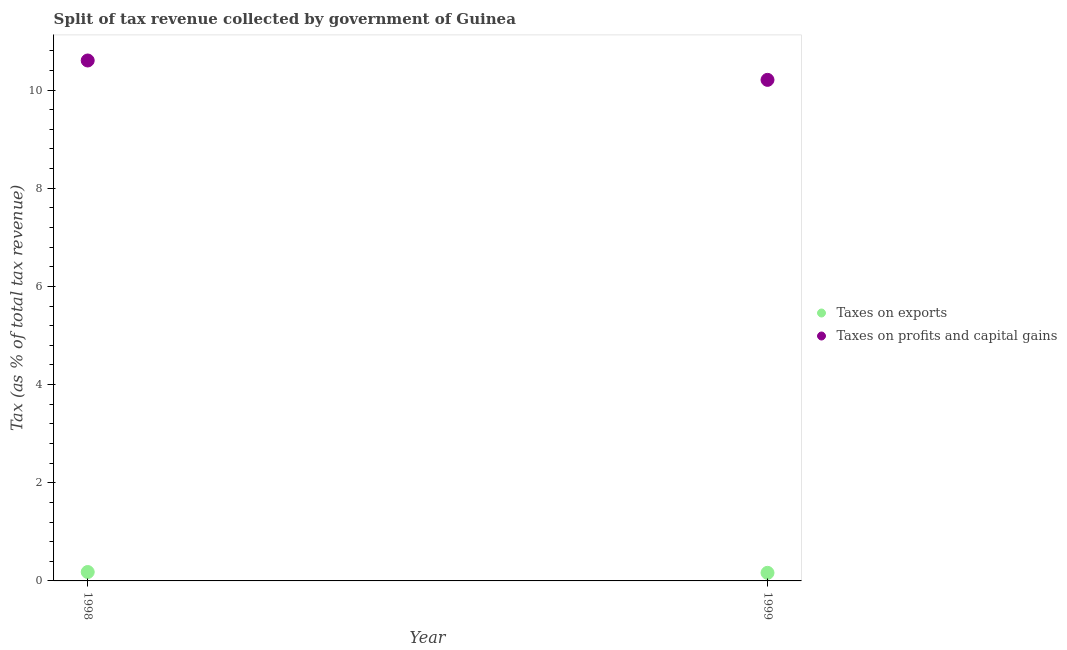How many different coloured dotlines are there?
Give a very brief answer. 2. Is the number of dotlines equal to the number of legend labels?
Offer a very short reply. Yes. What is the percentage of revenue obtained from taxes on profits and capital gains in 1999?
Ensure brevity in your answer.  10.21. Across all years, what is the maximum percentage of revenue obtained from taxes on exports?
Your response must be concise. 0.18. Across all years, what is the minimum percentage of revenue obtained from taxes on exports?
Make the answer very short. 0.16. In which year was the percentage of revenue obtained from taxes on exports minimum?
Provide a succinct answer. 1999. What is the total percentage of revenue obtained from taxes on profits and capital gains in the graph?
Give a very brief answer. 20.81. What is the difference between the percentage of revenue obtained from taxes on profits and capital gains in 1998 and that in 1999?
Keep it short and to the point. 0.39. What is the difference between the percentage of revenue obtained from taxes on exports in 1999 and the percentage of revenue obtained from taxes on profits and capital gains in 1998?
Offer a very short reply. -10.44. What is the average percentage of revenue obtained from taxes on profits and capital gains per year?
Your answer should be very brief. 10.4. In the year 1999, what is the difference between the percentage of revenue obtained from taxes on profits and capital gains and percentage of revenue obtained from taxes on exports?
Keep it short and to the point. 10.04. In how many years, is the percentage of revenue obtained from taxes on profits and capital gains greater than 2 %?
Give a very brief answer. 2. What is the ratio of the percentage of revenue obtained from taxes on exports in 1998 to that in 1999?
Ensure brevity in your answer.  1.1. In how many years, is the percentage of revenue obtained from taxes on exports greater than the average percentage of revenue obtained from taxes on exports taken over all years?
Your answer should be very brief. 1. Does the percentage of revenue obtained from taxes on exports monotonically increase over the years?
Your answer should be compact. No. Is the percentage of revenue obtained from taxes on profits and capital gains strictly less than the percentage of revenue obtained from taxes on exports over the years?
Your answer should be compact. No. How many dotlines are there?
Your response must be concise. 2. What is the difference between two consecutive major ticks on the Y-axis?
Your answer should be compact. 2. Are the values on the major ticks of Y-axis written in scientific E-notation?
Make the answer very short. No. Does the graph contain any zero values?
Your response must be concise. No. Does the graph contain grids?
Your response must be concise. No. Where does the legend appear in the graph?
Offer a very short reply. Center right. How are the legend labels stacked?
Keep it short and to the point. Vertical. What is the title of the graph?
Keep it short and to the point. Split of tax revenue collected by government of Guinea. Does "constant 2005 US$" appear as one of the legend labels in the graph?
Offer a very short reply. No. What is the label or title of the X-axis?
Offer a very short reply. Year. What is the label or title of the Y-axis?
Keep it short and to the point. Tax (as % of total tax revenue). What is the Tax (as % of total tax revenue) of Taxes on exports in 1998?
Provide a short and direct response. 0.18. What is the Tax (as % of total tax revenue) in Taxes on profits and capital gains in 1998?
Ensure brevity in your answer.  10.6. What is the Tax (as % of total tax revenue) in Taxes on exports in 1999?
Offer a very short reply. 0.16. What is the Tax (as % of total tax revenue) in Taxes on profits and capital gains in 1999?
Make the answer very short. 10.21. Across all years, what is the maximum Tax (as % of total tax revenue) in Taxes on exports?
Offer a terse response. 0.18. Across all years, what is the maximum Tax (as % of total tax revenue) of Taxes on profits and capital gains?
Make the answer very short. 10.6. Across all years, what is the minimum Tax (as % of total tax revenue) of Taxes on exports?
Provide a short and direct response. 0.16. Across all years, what is the minimum Tax (as % of total tax revenue) in Taxes on profits and capital gains?
Your answer should be compact. 10.21. What is the total Tax (as % of total tax revenue) in Taxes on exports in the graph?
Provide a short and direct response. 0.35. What is the total Tax (as % of total tax revenue) of Taxes on profits and capital gains in the graph?
Provide a succinct answer. 20.81. What is the difference between the Tax (as % of total tax revenue) of Taxes on exports in 1998 and that in 1999?
Ensure brevity in your answer.  0.02. What is the difference between the Tax (as % of total tax revenue) of Taxes on profits and capital gains in 1998 and that in 1999?
Offer a terse response. 0.39. What is the difference between the Tax (as % of total tax revenue) of Taxes on exports in 1998 and the Tax (as % of total tax revenue) of Taxes on profits and capital gains in 1999?
Offer a terse response. -10.03. What is the average Tax (as % of total tax revenue) in Taxes on exports per year?
Keep it short and to the point. 0.17. What is the average Tax (as % of total tax revenue) in Taxes on profits and capital gains per year?
Make the answer very short. 10.4. In the year 1998, what is the difference between the Tax (as % of total tax revenue) in Taxes on exports and Tax (as % of total tax revenue) in Taxes on profits and capital gains?
Provide a short and direct response. -10.42. In the year 1999, what is the difference between the Tax (as % of total tax revenue) of Taxes on exports and Tax (as % of total tax revenue) of Taxes on profits and capital gains?
Your answer should be compact. -10.04. What is the ratio of the Tax (as % of total tax revenue) of Taxes on exports in 1998 to that in 1999?
Offer a terse response. 1.1. What is the ratio of the Tax (as % of total tax revenue) of Taxes on profits and capital gains in 1998 to that in 1999?
Offer a terse response. 1.04. What is the difference between the highest and the second highest Tax (as % of total tax revenue) of Taxes on exports?
Your answer should be very brief. 0.02. What is the difference between the highest and the second highest Tax (as % of total tax revenue) in Taxes on profits and capital gains?
Make the answer very short. 0.39. What is the difference between the highest and the lowest Tax (as % of total tax revenue) in Taxes on exports?
Your answer should be compact. 0.02. What is the difference between the highest and the lowest Tax (as % of total tax revenue) of Taxes on profits and capital gains?
Ensure brevity in your answer.  0.39. 